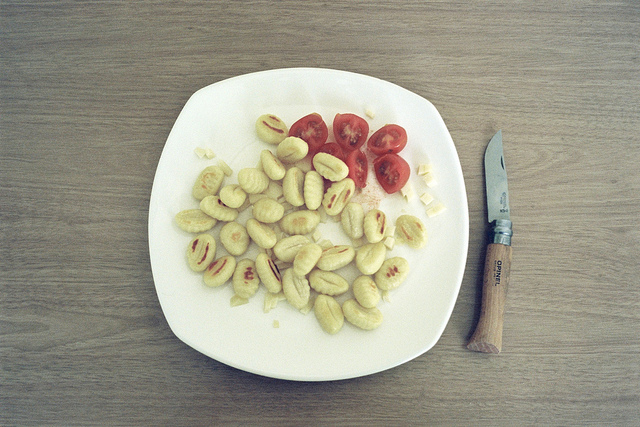<image>What type of pasta meal is on the table? I am not sure what type of pasta meal is on the table. It could be 'gnocchi', 'tortellini' or 'ravioli'. What type of pasta meal is on the table? It is ambiguous what type of pasta meal is on the table. It can be seen 'gnocchi', 'tortellini', 'gazpacho' or 'ravioli'. 